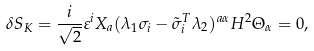<formula> <loc_0><loc_0><loc_500><loc_500>\delta { S _ { K } } = \frac { i } { \sqrt { 2 } } \varepsilon ^ { i } X _ { a } ( \lambda _ { 1 } \sigma _ { i } - \tilde { \sigma } ^ { T } _ { i } \lambda _ { 2 } ) ^ { a \alpha } H ^ { 2 } \Theta _ { \alpha } = 0 ,</formula> 